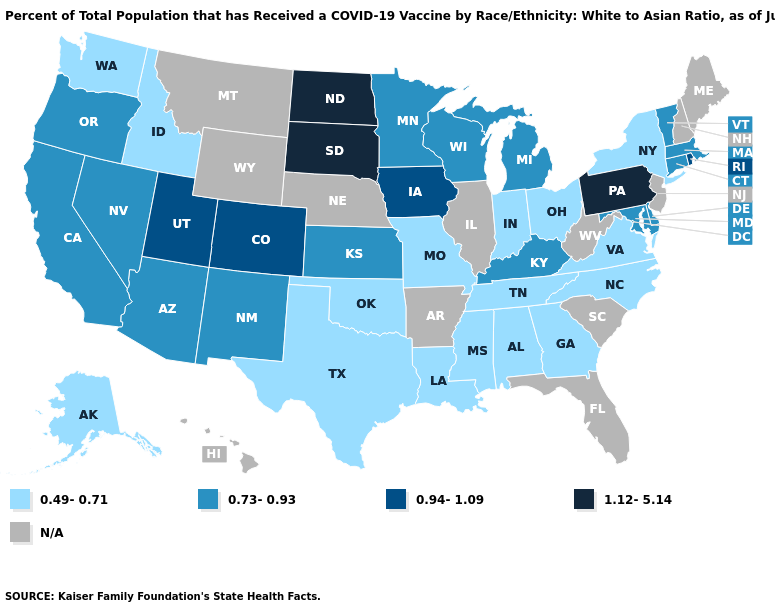Does Kentucky have the highest value in the USA?
Give a very brief answer. No. Does the map have missing data?
Give a very brief answer. Yes. Name the states that have a value in the range 0.73-0.93?
Concise answer only. Arizona, California, Connecticut, Delaware, Kansas, Kentucky, Maryland, Massachusetts, Michigan, Minnesota, Nevada, New Mexico, Oregon, Vermont, Wisconsin. What is the lowest value in states that border Wyoming?
Give a very brief answer. 0.49-0.71. What is the value of South Carolina?
Give a very brief answer. N/A. Name the states that have a value in the range N/A?
Concise answer only. Arkansas, Florida, Hawaii, Illinois, Maine, Montana, Nebraska, New Hampshire, New Jersey, South Carolina, West Virginia, Wyoming. Name the states that have a value in the range 0.73-0.93?
Short answer required. Arizona, California, Connecticut, Delaware, Kansas, Kentucky, Maryland, Massachusetts, Michigan, Minnesota, Nevada, New Mexico, Oregon, Vermont, Wisconsin. Does Arizona have the lowest value in the USA?
Short answer required. No. What is the value of North Dakota?
Write a very short answer. 1.12-5.14. Does the map have missing data?
Give a very brief answer. Yes. What is the value of South Carolina?
Keep it brief. N/A. Does South Dakota have the highest value in the MidWest?
Short answer required. Yes. Does the first symbol in the legend represent the smallest category?
Answer briefly. Yes. 